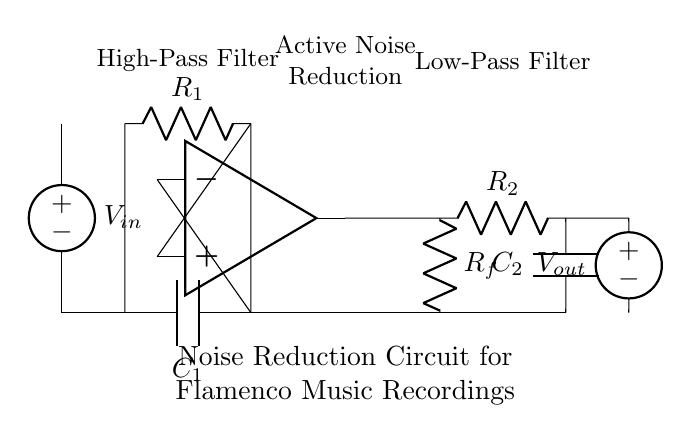What type of capacitors are used in this circuit? The circuit includes capacitors labeled C1 and C2. These are used in the high-pass and low-pass filter sections, respectively.
Answer: Capacitors What is the purpose of the operational amplifier in this circuit? The operational amplifier is used to amplify the input signal, making it suitable for the noise reduction process. It takes the output from the high-pass filter and adjusts the amplitude before applying the low-pass filter.
Answer: Signal amplification Which filter is located at the beginning of the circuit? The first filter in the circuit is a high-pass filter, indicated by the capacitor labeled C1 and resistor labeled R1. This filter removes low-frequency noise before the signal reaches the operational amplifier.
Answer: High-pass filter What is the role of the feedback resistor in the circuit? The feedback resistor labeled Rf connects the output of the operational amplifier back to its inverting input. This configuration sets the gain of the amplifier and helps control the noise reduction process by determining how much of the output is fed back into the circuit.
Answer: Gain control What is the overall function of this circuit? This circuit is designed to reduce noise in music recordings, particularly in flamenco music. It achieves this by first filtering out low frequencies (high-pass) to eliminate unwanted noise, amplifying the signal, and then filtering out high frequencies (low-pass) to ensure a clean output.
Answer: Noise reduction 